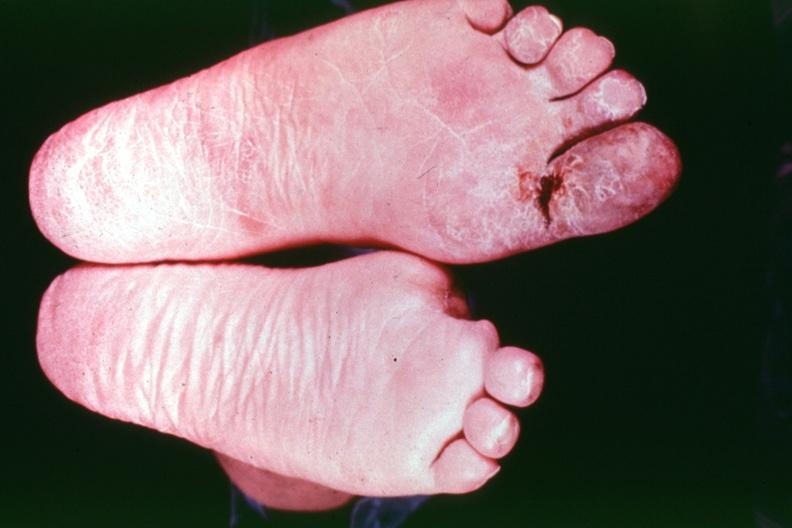does this image show buergers disease?
Answer the question using a single word or phrase. Yes 